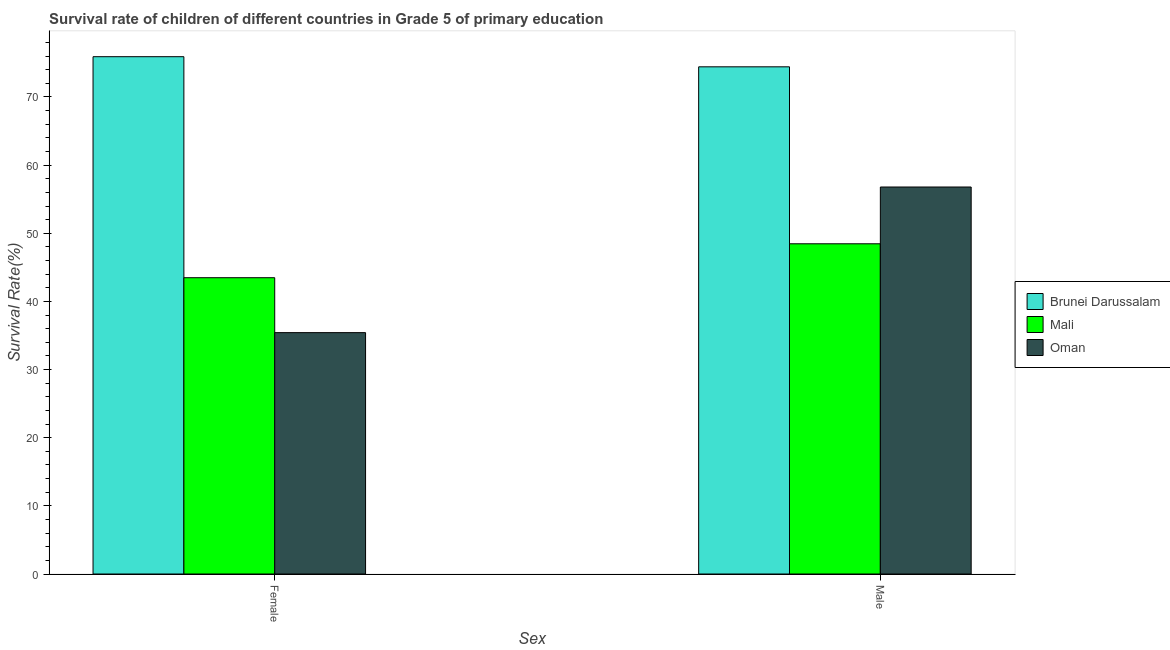Are the number of bars per tick equal to the number of legend labels?
Your answer should be compact. Yes. How many bars are there on the 2nd tick from the right?
Your answer should be compact. 3. What is the survival rate of male students in primary education in Brunei Darussalam?
Give a very brief answer. 74.42. Across all countries, what is the maximum survival rate of female students in primary education?
Offer a very short reply. 75.91. Across all countries, what is the minimum survival rate of female students in primary education?
Your answer should be very brief. 35.42. In which country was the survival rate of female students in primary education maximum?
Offer a terse response. Brunei Darussalam. In which country was the survival rate of male students in primary education minimum?
Your answer should be very brief. Mali. What is the total survival rate of female students in primary education in the graph?
Give a very brief answer. 154.81. What is the difference between the survival rate of male students in primary education in Brunei Darussalam and that in Oman?
Make the answer very short. 17.64. What is the difference between the survival rate of female students in primary education in Oman and the survival rate of male students in primary education in Mali?
Make the answer very short. -13.04. What is the average survival rate of male students in primary education per country?
Ensure brevity in your answer.  59.89. What is the difference between the survival rate of female students in primary education and survival rate of male students in primary education in Brunei Darussalam?
Make the answer very short. 1.49. In how many countries, is the survival rate of male students in primary education greater than 30 %?
Keep it short and to the point. 3. What is the ratio of the survival rate of female students in primary education in Mali to that in Brunei Darussalam?
Provide a short and direct response. 0.57. In how many countries, is the survival rate of male students in primary education greater than the average survival rate of male students in primary education taken over all countries?
Offer a very short reply. 1. What does the 3rd bar from the left in Female represents?
Your answer should be compact. Oman. What does the 1st bar from the right in Male represents?
Your response must be concise. Oman. How many bars are there?
Give a very brief answer. 6. Are all the bars in the graph horizontal?
Ensure brevity in your answer.  No. Does the graph contain any zero values?
Your response must be concise. No. How many legend labels are there?
Ensure brevity in your answer.  3. How are the legend labels stacked?
Provide a succinct answer. Vertical. What is the title of the graph?
Provide a succinct answer. Survival rate of children of different countries in Grade 5 of primary education. Does "Madagascar" appear as one of the legend labels in the graph?
Make the answer very short. No. What is the label or title of the X-axis?
Ensure brevity in your answer.  Sex. What is the label or title of the Y-axis?
Provide a succinct answer. Survival Rate(%). What is the Survival Rate(%) of Brunei Darussalam in Female?
Your answer should be compact. 75.91. What is the Survival Rate(%) in Mali in Female?
Provide a succinct answer. 43.48. What is the Survival Rate(%) of Oman in Female?
Provide a succinct answer. 35.42. What is the Survival Rate(%) of Brunei Darussalam in Male?
Keep it short and to the point. 74.42. What is the Survival Rate(%) in Mali in Male?
Ensure brevity in your answer.  48.46. What is the Survival Rate(%) of Oman in Male?
Give a very brief answer. 56.79. Across all Sex, what is the maximum Survival Rate(%) in Brunei Darussalam?
Keep it short and to the point. 75.91. Across all Sex, what is the maximum Survival Rate(%) of Mali?
Offer a terse response. 48.46. Across all Sex, what is the maximum Survival Rate(%) in Oman?
Offer a terse response. 56.79. Across all Sex, what is the minimum Survival Rate(%) of Brunei Darussalam?
Provide a succinct answer. 74.42. Across all Sex, what is the minimum Survival Rate(%) in Mali?
Provide a short and direct response. 43.48. Across all Sex, what is the minimum Survival Rate(%) of Oman?
Offer a terse response. 35.42. What is the total Survival Rate(%) in Brunei Darussalam in the graph?
Ensure brevity in your answer.  150.34. What is the total Survival Rate(%) in Mali in the graph?
Give a very brief answer. 91.93. What is the total Survival Rate(%) of Oman in the graph?
Provide a short and direct response. 92.21. What is the difference between the Survival Rate(%) of Brunei Darussalam in Female and that in Male?
Ensure brevity in your answer.  1.49. What is the difference between the Survival Rate(%) of Mali in Female and that in Male?
Your response must be concise. -4.98. What is the difference between the Survival Rate(%) in Oman in Female and that in Male?
Keep it short and to the point. -21.37. What is the difference between the Survival Rate(%) of Brunei Darussalam in Female and the Survival Rate(%) of Mali in Male?
Provide a succinct answer. 27.45. What is the difference between the Survival Rate(%) of Brunei Darussalam in Female and the Survival Rate(%) of Oman in Male?
Provide a short and direct response. 19.12. What is the difference between the Survival Rate(%) of Mali in Female and the Survival Rate(%) of Oman in Male?
Your answer should be compact. -13.31. What is the average Survival Rate(%) of Brunei Darussalam per Sex?
Offer a very short reply. 75.17. What is the average Survival Rate(%) in Mali per Sex?
Your answer should be compact. 45.97. What is the average Survival Rate(%) in Oman per Sex?
Ensure brevity in your answer.  46.1. What is the difference between the Survival Rate(%) in Brunei Darussalam and Survival Rate(%) in Mali in Female?
Provide a succinct answer. 32.43. What is the difference between the Survival Rate(%) in Brunei Darussalam and Survival Rate(%) in Oman in Female?
Provide a short and direct response. 40.49. What is the difference between the Survival Rate(%) of Mali and Survival Rate(%) of Oman in Female?
Ensure brevity in your answer.  8.06. What is the difference between the Survival Rate(%) in Brunei Darussalam and Survival Rate(%) in Mali in Male?
Provide a succinct answer. 25.97. What is the difference between the Survival Rate(%) of Brunei Darussalam and Survival Rate(%) of Oman in Male?
Offer a very short reply. 17.64. What is the difference between the Survival Rate(%) of Mali and Survival Rate(%) of Oman in Male?
Offer a very short reply. -8.33. What is the ratio of the Survival Rate(%) in Brunei Darussalam in Female to that in Male?
Your response must be concise. 1.02. What is the ratio of the Survival Rate(%) in Mali in Female to that in Male?
Make the answer very short. 0.9. What is the ratio of the Survival Rate(%) in Oman in Female to that in Male?
Your response must be concise. 0.62. What is the difference between the highest and the second highest Survival Rate(%) of Brunei Darussalam?
Make the answer very short. 1.49. What is the difference between the highest and the second highest Survival Rate(%) in Mali?
Offer a very short reply. 4.98. What is the difference between the highest and the second highest Survival Rate(%) in Oman?
Your response must be concise. 21.37. What is the difference between the highest and the lowest Survival Rate(%) of Brunei Darussalam?
Your answer should be very brief. 1.49. What is the difference between the highest and the lowest Survival Rate(%) in Mali?
Your answer should be compact. 4.98. What is the difference between the highest and the lowest Survival Rate(%) in Oman?
Ensure brevity in your answer.  21.37. 